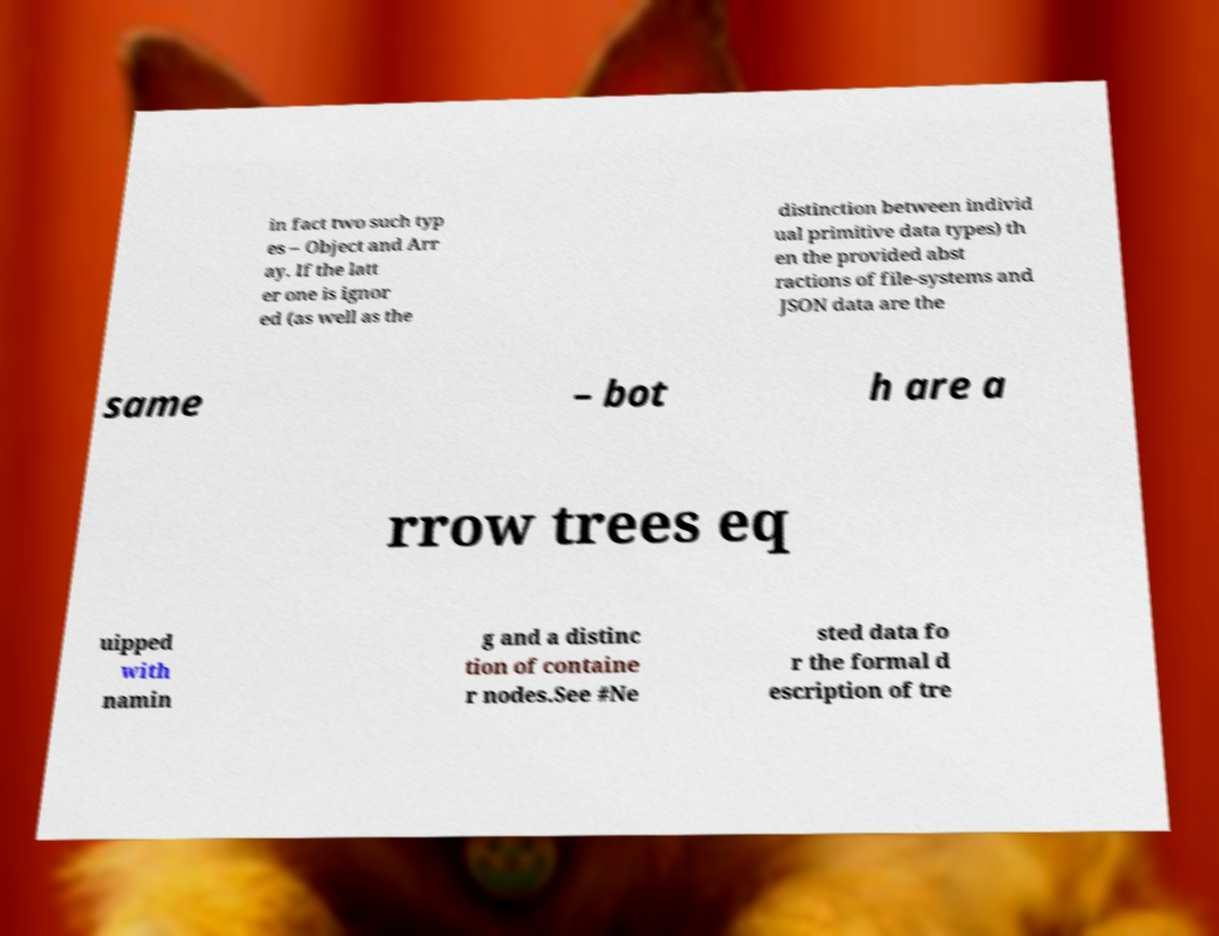There's text embedded in this image that I need extracted. Can you transcribe it verbatim? in fact two such typ es – Object and Arr ay. If the latt er one is ignor ed (as well as the distinction between individ ual primitive data types) th en the provided abst ractions of file-systems and JSON data are the same – bot h are a rrow trees eq uipped with namin g and a distinc tion of containe r nodes.See #Ne sted data fo r the formal d escription of tre 